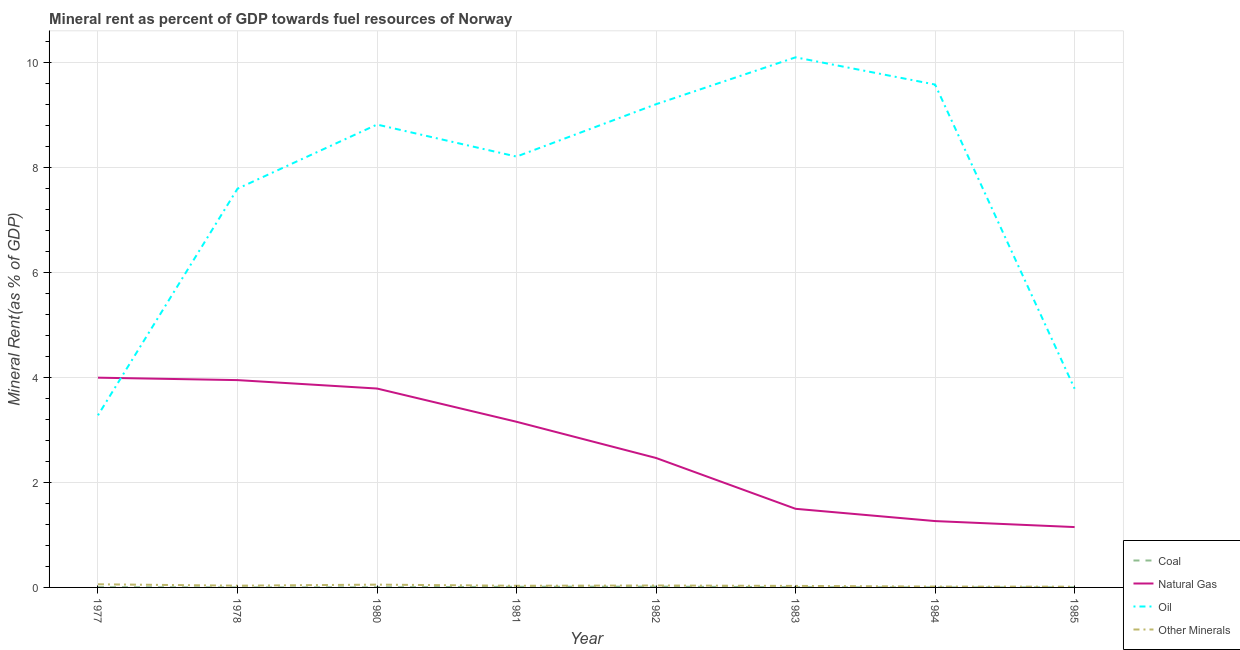Does the line corresponding to  rent of other minerals intersect with the line corresponding to natural gas rent?
Make the answer very short. No. Is the number of lines equal to the number of legend labels?
Ensure brevity in your answer.  Yes. What is the oil rent in 1981?
Provide a short and direct response. 8.21. Across all years, what is the maximum natural gas rent?
Your answer should be very brief. 4. Across all years, what is the minimum natural gas rent?
Your answer should be very brief. 1.15. What is the total oil rent in the graph?
Provide a short and direct response. 60.59. What is the difference between the oil rent in 1980 and that in 1983?
Make the answer very short. -1.28. What is the difference between the oil rent in 1982 and the coal rent in 1980?
Your answer should be very brief. 9.21. What is the average coal rent per year?
Provide a short and direct response. 0.01. In the year 1978, what is the difference between the  rent of other minerals and coal rent?
Ensure brevity in your answer.  0.03. What is the ratio of the coal rent in 1977 to that in 1980?
Your response must be concise. 1.97. What is the difference between the highest and the second highest  rent of other minerals?
Ensure brevity in your answer.  0.01. What is the difference between the highest and the lowest coal rent?
Offer a very short reply. 0.02. In how many years, is the  rent of other minerals greater than the average  rent of other minerals taken over all years?
Give a very brief answer. 3. Is the natural gas rent strictly less than the  rent of other minerals over the years?
Ensure brevity in your answer.  No. What is the difference between two consecutive major ticks on the Y-axis?
Offer a terse response. 2. Does the graph contain any zero values?
Offer a terse response. No. Where does the legend appear in the graph?
Offer a terse response. Bottom right. What is the title of the graph?
Your answer should be compact. Mineral rent as percent of GDP towards fuel resources of Norway. Does "Other greenhouse gases" appear as one of the legend labels in the graph?
Offer a very short reply. No. What is the label or title of the Y-axis?
Your answer should be very brief. Mineral Rent(as % of GDP). What is the Mineral Rent(as % of GDP) in Coal in 1977?
Provide a succinct answer. 0. What is the Mineral Rent(as % of GDP) of Natural Gas in 1977?
Provide a succinct answer. 4. What is the Mineral Rent(as % of GDP) in Oil in 1977?
Your response must be concise. 3.28. What is the Mineral Rent(as % of GDP) of Other Minerals in 1977?
Provide a short and direct response. 0.06. What is the Mineral Rent(as % of GDP) in Coal in 1978?
Your answer should be very brief. 0. What is the Mineral Rent(as % of GDP) of Natural Gas in 1978?
Provide a short and direct response. 3.95. What is the Mineral Rent(as % of GDP) of Oil in 1978?
Provide a succinct answer. 7.6. What is the Mineral Rent(as % of GDP) of Other Minerals in 1978?
Give a very brief answer. 0.03. What is the Mineral Rent(as % of GDP) in Coal in 1980?
Give a very brief answer. 0. What is the Mineral Rent(as % of GDP) of Natural Gas in 1980?
Make the answer very short. 3.79. What is the Mineral Rent(as % of GDP) of Oil in 1980?
Offer a very short reply. 8.82. What is the Mineral Rent(as % of GDP) in Other Minerals in 1980?
Make the answer very short. 0.05. What is the Mineral Rent(as % of GDP) in Coal in 1981?
Offer a very short reply. 0.01. What is the Mineral Rent(as % of GDP) of Natural Gas in 1981?
Provide a succinct answer. 3.16. What is the Mineral Rent(as % of GDP) of Oil in 1981?
Keep it short and to the point. 8.21. What is the Mineral Rent(as % of GDP) of Other Minerals in 1981?
Your response must be concise. 0.03. What is the Mineral Rent(as % of GDP) in Coal in 1982?
Make the answer very short. 0.02. What is the Mineral Rent(as % of GDP) in Natural Gas in 1982?
Offer a terse response. 2.47. What is the Mineral Rent(as % of GDP) in Oil in 1982?
Your response must be concise. 9.21. What is the Mineral Rent(as % of GDP) in Other Minerals in 1982?
Offer a very short reply. 0.04. What is the Mineral Rent(as % of GDP) of Coal in 1983?
Your response must be concise. 0. What is the Mineral Rent(as % of GDP) of Natural Gas in 1983?
Give a very brief answer. 1.5. What is the Mineral Rent(as % of GDP) in Oil in 1983?
Your answer should be compact. 10.1. What is the Mineral Rent(as % of GDP) of Other Minerals in 1983?
Your answer should be very brief. 0.03. What is the Mineral Rent(as % of GDP) in Coal in 1984?
Ensure brevity in your answer.  0. What is the Mineral Rent(as % of GDP) of Natural Gas in 1984?
Provide a succinct answer. 1.26. What is the Mineral Rent(as % of GDP) in Oil in 1984?
Your answer should be compact. 9.58. What is the Mineral Rent(as % of GDP) in Other Minerals in 1984?
Provide a succinct answer. 0.02. What is the Mineral Rent(as % of GDP) in Coal in 1985?
Ensure brevity in your answer.  0. What is the Mineral Rent(as % of GDP) in Natural Gas in 1985?
Offer a terse response. 1.15. What is the Mineral Rent(as % of GDP) in Oil in 1985?
Ensure brevity in your answer.  3.79. What is the Mineral Rent(as % of GDP) in Other Minerals in 1985?
Keep it short and to the point. 0.01. Across all years, what is the maximum Mineral Rent(as % of GDP) of Coal?
Offer a very short reply. 0.02. Across all years, what is the maximum Mineral Rent(as % of GDP) of Natural Gas?
Offer a very short reply. 4. Across all years, what is the maximum Mineral Rent(as % of GDP) in Oil?
Offer a very short reply. 10.1. Across all years, what is the maximum Mineral Rent(as % of GDP) of Other Minerals?
Make the answer very short. 0.06. Across all years, what is the minimum Mineral Rent(as % of GDP) in Coal?
Your answer should be compact. 0. Across all years, what is the minimum Mineral Rent(as % of GDP) in Natural Gas?
Your answer should be very brief. 1.15. Across all years, what is the minimum Mineral Rent(as % of GDP) in Oil?
Offer a terse response. 3.28. Across all years, what is the minimum Mineral Rent(as % of GDP) of Other Minerals?
Offer a terse response. 0.01. What is the total Mineral Rent(as % of GDP) in Coal in the graph?
Make the answer very short. 0.04. What is the total Mineral Rent(as % of GDP) of Natural Gas in the graph?
Your response must be concise. 21.27. What is the total Mineral Rent(as % of GDP) of Oil in the graph?
Give a very brief answer. 60.59. What is the total Mineral Rent(as % of GDP) of Other Minerals in the graph?
Your response must be concise. 0.28. What is the difference between the Mineral Rent(as % of GDP) in Coal in 1977 and that in 1978?
Give a very brief answer. 0. What is the difference between the Mineral Rent(as % of GDP) of Natural Gas in 1977 and that in 1978?
Offer a very short reply. 0.05. What is the difference between the Mineral Rent(as % of GDP) of Oil in 1977 and that in 1978?
Your response must be concise. -4.32. What is the difference between the Mineral Rent(as % of GDP) of Other Minerals in 1977 and that in 1978?
Keep it short and to the point. 0.03. What is the difference between the Mineral Rent(as % of GDP) of Coal in 1977 and that in 1980?
Offer a very short reply. 0. What is the difference between the Mineral Rent(as % of GDP) in Natural Gas in 1977 and that in 1980?
Your answer should be very brief. 0.21. What is the difference between the Mineral Rent(as % of GDP) of Oil in 1977 and that in 1980?
Ensure brevity in your answer.  -5.54. What is the difference between the Mineral Rent(as % of GDP) in Other Minerals in 1977 and that in 1980?
Offer a very short reply. 0.01. What is the difference between the Mineral Rent(as % of GDP) of Coal in 1977 and that in 1981?
Your answer should be very brief. -0.01. What is the difference between the Mineral Rent(as % of GDP) of Natural Gas in 1977 and that in 1981?
Your response must be concise. 0.84. What is the difference between the Mineral Rent(as % of GDP) of Oil in 1977 and that in 1981?
Make the answer very short. -4.93. What is the difference between the Mineral Rent(as % of GDP) in Other Minerals in 1977 and that in 1981?
Offer a terse response. 0.03. What is the difference between the Mineral Rent(as % of GDP) of Coal in 1977 and that in 1982?
Your response must be concise. -0.01. What is the difference between the Mineral Rent(as % of GDP) of Natural Gas in 1977 and that in 1982?
Your answer should be very brief. 1.53. What is the difference between the Mineral Rent(as % of GDP) in Oil in 1977 and that in 1982?
Provide a short and direct response. -5.93. What is the difference between the Mineral Rent(as % of GDP) in Other Minerals in 1977 and that in 1982?
Your answer should be very brief. 0.02. What is the difference between the Mineral Rent(as % of GDP) of Natural Gas in 1977 and that in 1983?
Your answer should be compact. 2.5. What is the difference between the Mineral Rent(as % of GDP) of Oil in 1977 and that in 1983?
Provide a short and direct response. -6.82. What is the difference between the Mineral Rent(as % of GDP) of Other Minerals in 1977 and that in 1983?
Ensure brevity in your answer.  0.03. What is the difference between the Mineral Rent(as % of GDP) of Coal in 1977 and that in 1984?
Provide a succinct answer. 0. What is the difference between the Mineral Rent(as % of GDP) in Natural Gas in 1977 and that in 1984?
Your answer should be very brief. 2.73. What is the difference between the Mineral Rent(as % of GDP) of Oil in 1977 and that in 1984?
Your answer should be very brief. -6.3. What is the difference between the Mineral Rent(as % of GDP) of Other Minerals in 1977 and that in 1984?
Provide a succinct answer. 0.04. What is the difference between the Mineral Rent(as % of GDP) in Coal in 1977 and that in 1985?
Keep it short and to the point. 0. What is the difference between the Mineral Rent(as % of GDP) of Natural Gas in 1977 and that in 1985?
Offer a terse response. 2.85. What is the difference between the Mineral Rent(as % of GDP) of Oil in 1977 and that in 1985?
Make the answer very short. -0.51. What is the difference between the Mineral Rent(as % of GDP) of Other Minerals in 1977 and that in 1985?
Your answer should be very brief. 0.05. What is the difference between the Mineral Rent(as % of GDP) in Coal in 1978 and that in 1980?
Keep it short and to the point. -0. What is the difference between the Mineral Rent(as % of GDP) of Natural Gas in 1978 and that in 1980?
Provide a succinct answer. 0.16. What is the difference between the Mineral Rent(as % of GDP) of Oil in 1978 and that in 1980?
Give a very brief answer. -1.22. What is the difference between the Mineral Rent(as % of GDP) of Other Minerals in 1978 and that in 1980?
Ensure brevity in your answer.  -0.02. What is the difference between the Mineral Rent(as % of GDP) in Coal in 1978 and that in 1981?
Provide a short and direct response. -0.01. What is the difference between the Mineral Rent(as % of GDP) of Natural Gas in 1978 and that in 1981?
Make the answer very short. 0.79. What is the difference between the Mineral Rent(as % of GDP) in Oil in 1978 and that in 1981?
Give a very brief answer. -0.61. What is the difference between the Mineral Rent(as % of GDP) in Other Minerals in 1978 and that in 1981?
Offer a very short reply. 0. What is the difference between the Mineral Rent(as % of GDP) in Coal in 1978 and that in 1982?
Your response must be concise. -0.01. What is the difference between the Mineral Rent(as % of GDP) in Natural Gas in 1978 and that in 1982?
Keep it short and to the point. 1.48. What is the difference between the Mineral Rent(as % of GDP) in Oil in 1978 and that in 1982?
Your answer should be compact. -1.61. What is the difference between the Mineral Rent(as % of GDP) in Other Minerals in 1978 and that in 1982?
Provide a short and direct response. -0. What is the difference between the Mineral Rent(as % of GDP) in Coal in 1978 and that in 1983?
Your answer should be compact. -0. What is the difference between the Mineral Rent(as % of GDP) in Natural Gas in 1978 and that in 1983?
Your answer should be very brief. 2.45. What is the difference between the Mineral Rent(as % of GDP) of Oil in 1978 and that in 1983?
Offer a terse response. -2.5. What is the difference between the Mineral Rent(as % of GDP) of Other Minerals in 1978 and that in 1983?
Ensure brevity in your answer.  0. What is the difference between the Mineral Rent(as % of GDP) in Natural Gas in 1978 and that in 1984?
Your response must be concise. 2.69. What is the difference between the Mineral Rent(as % of GDP) of Oil in 1978 and that in 1984?
Offer a terse response. -1.98. What is the difference between the Mineral Rent(as % of GDP) in Other Minerals in 1978 and that in 1984?
Your answer should be compact. 0.02. What is the difference between the Mineral Rent(as % of GDP) in Coal in 1978 and that in 1985?
Give a very brief answer. -0. What is the difference between the Mineral Rent(as % of GDP) in Natural Gas in 1978 and that in 1985?
Keep it short and to the point. 2.8. What is the difference between the Mineral Rent(as % of GDP) of Oil in 1978 and that in 1985?
Offer a very short reply. 3.81. What is the difference between the Mineral Rent(as % of GDP) of Other Minerals in 1978 and that in 1985?
Your response must be concise. 0.02. What is the difference between the Mineral Rent(as % of GDP) in Coal in 1980 and that in 1981?
Your answer should be very brief. -0.01. What is the difference between the Mineral Rent(as % of GDP) in Natural Gas in 1980 and that in 1981?
Your answer should be compact. 0.63. What is the difference between the Mineral Rent(as % of GDP) of Oil in 1980 and that in 1981?
Offer a very short reply. 0.61. What is the difference between the Mineral Rent(as % of GDP) of Other Minerals in 1980 and that in 1981?
Offer a very short reply. 0.02. What is the difference between the Mineral Rent(as % of GDP) in Coal in 1980 and that in 1982?
Give a very brief answer. -0.01. What is the difference between the Mineral Rent(as % of GDP) in Natural Gas in 1980 and that in 1982?
Keep it short and to the point. 1.32. What is the difference between the Mineral Rent(as % of GDP) of Oil in 1980 and that in 1982?
Make the answer very short. -0.39. What is the difference between the Mineral Rent(as % of GDP) of Other Minerals in 1980 and that in 1982?
Offer a terse response. 0.02. What is the difference between the Mineral Rent(as % of GDP) in Coal in 1980 and that in 1983?
Keep it short and to the point. -0. What is the difference between the Mineral Rent(as % of GDP) in Natural Gas in 1980 and that in 1983?
Your answer should be compact. 2.29. What is the difference between the Mineral Rent(as % of GDP) of Oil in 1980 and that in 1983?
Provide a succinct answer. -1.28. What is the difference between the Mineral Rent(as % of GDP) in Other Minerals in 1980 and that in 1983?
Keep it short and to the point. 0.02. What is the difference between the Mineral Rent(as % of GDP) in Coal in 1980 and that in 1984?
Offer a terse response. 0. What is the difference between the Mineral Rent(as % of GDP) in Natural Gas in 1980 and that in 1984?
Ensure brevity in your answer.  2.53. What is the difference between the Mineral Rent(as % of GDP) of Oil in 1980 and that in 1984?
Your answer should be very brief. -0.76. What is the difference between the Mineral Rent(as % of GDP) of Other Minerals in 1980 and that in 1984?
Your answer should be compact. 0.04. What is the difference between the Mineral Rent(as % of GDP) of Coal in 1980 and that in 1985?
Your answer should be compact. -0. What is the difference between the Mineral Rent(as % of GDP) in Natural Gas in 1980 and that in 1985?
Keep it short and to the point. 2.64. What is the difference between the Mineral Rent(as % of GDP) of Oil in 1980 and that in 1985?
Give a very brief answer. 5.03. What is the difference between the Mineral Rent(as % of GDP) of Other Minerals in 1980 and that in 1985?
Ensure brevity in your answer.  0.04. What is the difference between the Mineral Rent(as % of GDP) in Coal in 1981 and that in 1982?
Your answer should be compact. -0. What is the difference between the Mineral Rent(as % of GDP) in Natural Gas in 1981 and that in 1982?
Offer a very short reply. 0.69. What is the difference between the Mineral Rent(as % of GDP) in Oil in 1981 and that in 1982?
Provide a succinct answer. -1. What is the difference between the Mineral Rent(as % of GDP) of Other Minerals in 1981 and that in 1982?
Provide a succinct answer. -0.01. What is the difference between the Mineral Rent(as % of GDP) of Coal in 1981 and that in 1983?
Provide a succinct answer. 0.01. What is the difference between the Mineral Rent(as % of GDP) in Natural Gas in 1981 and that in 1983?
Provide a succinct answer. 1.66. What is the difference between the Mineral Rent(as % of GDP) in Oil in 1981 and that in 1983?
Provide a short and direct response. -1.89. What is the difference between the Mineral Rent(as % of GDP) of Other Minerals in 1981 and that in 1983?
Your answer should be very brief. 0. What is the difference between the Mineral Rent(as % of GDP) in Coal in 1981 and that in 1984?
Ensure brevity in your answer.  0.01. What is the difference between the Mineral Rent(as % of GDP) in Natural Gas in 1981 and that in 1984?
Your answer should be compact. 1.89. What is the difference between the Mineral Rent(as % of GDP) in Oil in 1981 and that in 1984?
Provide a succinct answer. -1.37. What is the difference between the Mineral Rent(as % of GDP) in Other Minerals in 1981 and that in 1984?
Your answer should be compact. 0.02. What is the difference between the Mineral Rent(as % of GDP) in Coal in 1981 and that in 1985?
Make the answer very short. 0.01. What is the difference between the Mineral Rent(as % of GDP) in Natural Gas in 1981 and that in 1985?
Provide a succinct answer. 2.01. What is the difference between the Mineral Rent(as % of GDP) of Oil in 1981 and that in 1985?
Provide a short and direct response. 4.42. What is the difference between the Mineral Rent(as % of GDP) in Other Minerals in 1981 and that in 1985?
Keep it short and to the point. 0.02. What is the difference between the Mineral Rent(as % of GDP) of Coal in 1982 and that in 1983?
Your answer should be very brief. 0.01. What is the difference between the Mineral Rent(as % of GDP) of Natural Gas in 1982 and that in 1983?
Keep it short and to the point. 0.97. What is the difference between the Mineral Rent(as % of GDP) in Oil in 1982 and that in 1983?
Offer a very short reply. -0.89. What is the difference between the Mineral Rent(as % of GDP) of Other Minerals in 1982 and that in 1983?
Offer a very short reply. 0.01. What is the difference between the Mineral Rent(as % of GDP) of Coal in 1982 and that in 1984?
Ensure brevity in your answer.  0.02. What is the difference between the Mineral Rent(as % of GDP) of Natural Gas in 1982 and that in 1984?
Your answer should be very brief. 1.2. What is the difference between the Mineral Rent(as % of GDP) in Oil in 1982 and that in 1984?
Your answer should be compact. -0.37. What is the difference between the Mineral Rent(as % of GDP) in Other Minerals in 1982 and that in 1984?
Provide a succinct answer. 0.02. What is the difference between the Mineral Rent(as % of GDP) in Coal in 1982 and that in 1985?
Provide a succinct answer. 0.01. What is the difference between the Mineral Rent(as % of GDP) in Natural Gas in 1982 and that in 1985?
Provide a succinct answer. 1.32. What is the difference between the Mineral Rent(as % of GDP) in Oil in 1982 and that in 1985?
Ensure brevity in your answer.  5.42. What is the difference between the Mineral Rent(as % of GDP) in Other Minerals in 1982 and that in 1985?
Provide a short and direct response. 0.02. What is the difference between the Mineral Rent(as % of GDP) in Coal in 1983 and that in 1984?
Offer a very short reply. 0. What is the difference between the Mineral Rent(as % of GDP) in Natural Gas in 1983 and that in 1984?
Offer a very short reply. 0.23. What is the difference between the Mineral Rent(as % of GDP) in Oil in 1983 and that in 1984?
Provide a succinct answer. 0.52. What is the difference between the Mineral Rent(as % of GDP) of Other Minerals in 1983 and that in 1984?
Your answer should be very brief. 0.01. What is the difference between the Mineral Rent(as % of GDP) of Coal in 1983 and that in 1985?
Give a very brief answer. 0. What is the difference between the Mineral Rent(as % of GDP) of Natural Gas in 1983 and that in 1985?
Provide a succinct answer. 0.35. What is the difference between the Mineral Rent(as % of GDP) of Oil in 1983 and that in 1985?
Your answer should be compact. 6.32. What is the difference between the Mineral Rent(as % of GDP) in Other Minerals in 1983 and that in 1985?
Make the answer very short. 0.01. What is the difference between the Mineral Rent(as % of GDP) in Coal in 1984 and that in 1985?
Your answer should be compact. -0. What is the difference between the Mineral Rent(as % of GDP) in Natural Gas in 1984 and that in 1985?
Your answer should be compact. 0.11. What is the difference between the Mineral Rent(as % of GDP) of Oil in 1984 and that in 1985?
Provide a succinct answer. 5.8. What is the difference between the Mineral Rent(as % of GDP) of Other Minerals in 1984 and that in 1985?
Your answer should be compact. 0. What is the difference between the Mineral Rent(as % of GDP) in Coal in 1977 and the Mineral Rent(as % of GDP) in Natural Gas in 1978?
Offer a very short reply. -3.95. What is the difference between the Mineral Rent(as % of GDP) of Coal in 1977 and the Mineral Rent(as % of GDP) of Oil in 1978?
Provide a succinct answer. -7.59. What is the difference between the Mineral Rent(as % of GDP) in Coal in 1977 and the Mineral Rent(as % of GDP) in Other Minerals in 1978?
Offer a very short reply. -0.03. What is the difference between the Mineral Rent(as % of GDP) of Natural Gas in 1977 and the Mineral Rent(as % of GDP) of Oil in 1978?
Your response must be concise. -3.6. What is the difference between the Mineral Rent(as % of GDP) in Natural Gas in 1977 and the Mineral Rent(as % of GDP) in Other Minerals in 1978?
Your response must be concise. 3.96. What is the difference between the Mineral Rent(as % of GDP) of Oil in 1977 and the Mineral Rent(as % of GDP) of Other Minerals in 1978?
Give a very brief answer. 3.25. What is the difference between the Mineral Rent(as % of GDP) of Coal in 1977 and the Mineral Rent(as % of GDP) of Natural Gas in 1980?
Provide a succinct answer. -3.79. What is the difference between the Mineral Rent(as % of GDP) of Coal in 1977 and the Mineral Rent(as % of GDP) of Oil in 1980?
Provide a short and direct response. -8.82. What is the difference between the Mineral Rent(as % of GDP) in Coal in 1977 and the Mineral Rent(as % of GDP) in Other Minerals in 1980?
Keep it short and to the point. -0.05. What is the difference between the Mineral Rent(as % of GDP) in Natural Gas in 1977 and the Mineral Rent(as % of GDP) in Oil in 1980?
Provide a short and direct response. -4.82. What is the difference between the Mineral Rent(as % of GDP) in Natural Gas in 1977 and the Mineral Rent(as % of GDP) in Other Minerals in 1980?
Your answer should be compact. 3.94. What is the difference between the Mineral Rent(as % of GDP) in Oil in 1977 and the Mineral Rent(as % of GDP) in Other Minerals in 1980?
Offer a very short reply. 3.23. What is the difference between the Mineral Rent(as % of GDP) in Coal in 1977 and the Mineral Rent(as % of GDP) in Natural Gas in 1981?
Offer a terse response. -3.15. What is the difference between the Mineral Rent(as % of GDP) of Coal in 1977 and the Mineral Rent(as % of GDP) of Oil in 1981?
Your answer should be compact. -8.21. What is the difference between the Mineral Rent(as % of GDP) in Coal in 1977 and the Mineral Rent(as % of GDP) in Other Minerals in 1981?
Give a very brief answer. -0.03. What is the difference between the Mineral Rent(as % of GDP) of Natural Gas in 1977 and the Mineral Rent(as % of GDP) of Oil in 1981?
Provide a short and direct response. -4.21. What is the difference between the Mineral Rent(as % of GDP) in Natural Gas in 1977 and the Mineral Rent(as % of GDP) in Other Minerals in 1981?
Provide a succinct answer. 3.97. What is the difference between the Mineral Rent(as % of GDP) of Oil in 1977 and the Mineral Rent(as % of GDP) of Other Minerals in 1981?
Offer a very short reply. 3.25. What is the difference between the Mineral Rent(as % of GDP) in Coal in 1977 and the Mineral Rent(as % of GDP) in Natural Gas in 1982?
Provide a succinct answer. -2.46. What is the difference between the Mineral Rent(as % of GDP) of Coal in 1977 and the Mineral Rent(as % of GDP) of Oil in 1982?
Ensure brevity in your answer.  -9.2. What is the difference between the Mineral Rent(as % of GDP) of Coal in 1977 and the Mineral Rent(as % of GDP) of Other Minerals in 1982?
Keep it short and to the point. -0.03. What is the difference between the Mineral Rent(as % of GDP) in Natural Gas in 1977 and the Mineral Rent(as % of GDP) in Oil in 1982?
Offer a very short reply. -5.21. What is the difference between the Mineral Rent(as % of GDP) in Natural Gas in 1977 and the Mineral Rent(as % of GDP) in Other Minerals in 1982?
Offer a terse response. 3.96. What is the difference between the Mineral Rent(as % of GDP) in Oil in 1977 and the Mineral Rent(as % of GDP) in Other Minerals in 1982?
Ensure brevity in your answer.  3.24. What is the difference between the Mineral Rent(as % of GDP) in Coal in 1977 and the Mineral Rent(as % of GDP) in Natural Gas in 1983?
Give a very brief answer. -1.49. What is the difference between the Mineral Rent(as % of GDP) in Coal in 1977 and the Mineral Rent(as % of GDP) in Oil in 1983?
Provide a short and direct response. -10.1. What is the difference between the Mineral Rent(as % of GDP) of Coal in 1977 and the Mineral Rent(as % of GDP) of Other Minerals in 1983?
Keep it short and to the point. -0.02. What is the difference between the Mineral Rent(as % of GDP) of Natural Gas in 1977 and the Mineral Rent(as % of GDP) of Oil in 1983?
Keep it short and to the point. -6.1. What is the difference between the Mineral Rent(as % of GDP) in Natural Gas in 1977 and the Mineral Rent(as % of GDP) in Other Minerals in 1983?
Your answer should be compact. 3.97. What is the difference between the Mineral Rent(as % of GDP) in Oil in 1977 and the Mineral Rent(as % of GDP) in Other Minerals in 1983?
Your response must be concise. 3.25. What is the difference between the Mineral Rent(as % of GDP) in Coal in 1977 and the Mineral Rent(as % of GDP) in Natural Gas in 1984?
Offer a terse response. -1.26. What is the difference between the Mineral Rent(as % of GDP) in Coal in 1977 and the Mineral Rent(as % of GDP) in Oil in 1984?
Give a very brief answer. -9.58. What is the difference between the Mineral Rent(as % of GDP) in Coal in 1977 and the Mineral Rent(as % of GDP) in Other Minerals in 1984?
Offer a terse response. -0.01. What is the difference between the Mineral Rent(as % of GDP) of Natural Gas in 1977 and the Mineral Rent(as % of GDP) of Oil in 1984?
Offer a terse response. -5.59. What is the difference between the Mineral Rent(as % of GDP) of Natural Gas in 1977 and the Mineral Rent(as % of GDP) of Other Minerals in 1984?
Offer a very short reply. 3.98. What is the difference between the Mineral Rent(as % of GDP) in Oil in 1977 and the Mineral Rent(as % of GDP) in Other Minerals in 1984?
Your response must be concise. 3.26. What is the difference between the Mineral Rent(as % of GDP) in Coal in 1977 and the Mineral Rent(as % of GDP) in Natural Gas in 1985?
Your response must be concise. -1.15. What is the difference between the Mineral Rent(as % of GDP) of Coal in 1977 and the Mineral Rent(as % of GDP) of Oil in 1985?
Offer a terse response. -3.78. What is the difference between the Mineral Rent(as % of GDP) in Coal in 1977 and the Mineral Rent(as % of GDP) in Other Minerals in 1985?
Your answer should be very brief. -0.01. What is the difference between the Mineral Rent(as % of GDP) in Natural Gas in 1977 and the Mineral Rent(as % of GDP) in Oil in 1985?
Keep it short and to the point. 0.21. What is the difference between the Mineral Rent(as % of GDP) in Natural Gas in 1977 and the Mineral Rent(as % of GDP) in Other Minerals in 1985?
Your answer should be compact. 3.98. What is the difference between the Mineral Rent(as % of GDP) in Oil in 1977 and the Mineral Rent(as % of GDP) in Other Minerals in 1985?
Make the answer very short. 3.27. What is the difference between the Mineral Rent(as % of GDP) in Coal in 1978 and the Mineral Rent(as % of GDP) in Natural Gas in 1980?
Offer a very short reply. -3.79. What is the difference between the Mineral Rent(as % of GDP) in Coal in 1978 and the Mineral Rent(as % of GDP) in Oil in 1980?
Your answer should be compact. -8.82. What is the difference between the Mineral Rent(as % of GDP) in Coal in 1978 and the Mineral Rent(as % of GDP) in Other Minerals in 1980?
Make the answer very short. -0.05. What is the difference between the Mineral Rent(as % of GDP) in Natural Gas in 1978 and the Mineral Rent(as % of GDP) in Oil in 1980?
Your response must be concise. -4.87. What is the difference between the Mineral Rent(as % of GDP) in Natural Gas in 1978 and the Mineral Rent(as % of GDP) in Other Minerals in 1980?
Your answer should be very brief. 3.9. What is the difference between the Mineral Rent(as % of GDP) of Oil in 1978 and the Mineral Rent(as % of GDP) of Other Minerals in 1980?
Give a very brief answer. 7.55. What is the difference between the Mineral Rent(as % of GDP) in Coal in 1978 and the Mineral Rent(as % of GDP) in Natural Gas in 1981?
Provide a succinct answer. -3.16. What is the difference between the Mineral Rent(as % of GDP) in Coal in 1978 and the Mineral Rent(as % of GDP) in Oil in 1981?
Provide a succinct answer. -8.21. What is the difference between the Mineral Rent(as % of GDP) of Coal in 1978 and the Mineral Rent(as % of GDP) of Other Minerals in 1981?
Your answer should be very brief. -0.03. What is the difference between the Mineral Rent(as % of GDP) of Natural Gas in 1978 and the Mineral Rent(as % of GDP) of Oil in 1981?
Provide a succinct answer. -4.26. What is the difference between the Mineral Rent(as % of GDP) of Natural Gas in 1978 and the Mineral Rent(as % of GDP) of Other Minerals in 1981?
Ensure brevity in your answer.  3.92. What is the difference between the Mineral Rent(as % of GDP) of Oil in 1978 and the Mineral Rent(as % of GDP) of Other Minerals in 1981?
Your response must be concise. 7.57. What is the difference between the Mineral Rent(as % of GDP) in Coal in 1978 and the Mineral Rent(as % of GDP) in Natural Gas in 1982?
Your response must be concise. -2.47. What is the difference between the Mineral Rent(as % of GDP) in Coal in 1978 and the Mineral Rent(as % of GDP) in Oil in 1982?
Give a very brief answer. -9.21. What is the difference between the Mineral Rent(as % of GDP) of Coal in 1978 and the Mineral Rent(as % of GDP) of Other Minerals in 1982?
Your answer should be compact. -0.04. What is the difference between the Mineral Rent(as % of GDP) of Natural Gas in 1978 and the Mineral Rent(as % of GDP) of Oil in 1982?
Keep it short and to the point. -5.26. What is the difference between the Mineral Rent(as % of GDP) in Natural Gas in 1978 and the Mineral Rent(as % of GDP) in Other Minerals in 1982?
Make the answer very short. 3.91. What is the difference between the Mineral Rent(as % of GDP) of Oil in 1978 and the Mineral Rent(as % of GDP) of Other Minerals in 1982?
Your response must be concise. 7.56. What is the difference between the Mineral Rent(as % of GDP) in Coal in 1978 and the Mineral Rent(as % of GDP) in Natural Gas in 1983?
Ensure brevity in your answer.  -1.5. What is the difference between the Mineral Rent(as % of GDP) of Coal in 1978 and the Mineral Rent(as % of GDP) of Oil in 1983?
Offer a very short reply. -10.1. What is the difference between the Mineral Rent(as % of GDP) of Coal in 1978 and the Mineral Rent(as % of GDP) of Other Minerals in 1983?
Provide a short and direct response. -0.03. What is the difference between the Mineral Rent(as % of GDP) in Natural Gas in 1978 and the Mineral Rent(as % of GDP) in Oil in 1983?
Keep it short and to the point. -6.15. What is the difference between the Mineral Rent(as % of GDP) of Natural Gas in 1978 and the Mineral Rent(as % of GDP) of Other Minerals in 1983?
Offer a terse response. 3.92. What is the difference between the Mineral Rent(as % of GDP) of Oil in 1978 and the Mineral Rent(as % of GDP) of Other Minerals in 1983?
Provide a short and direct response. 7.57. What is the difference between the Mineral Rent(as % of GDP) in Coal in 1978 and the Mineral Rent(as % of GDP) in Natural Gas in 1984?
Keep it short and to the point. -1.26. What is the difference between the Mineral Rent(as % of GDP) of Coal in 1978 and the Mineral Rent(as % of GDP) of Oil in 1984?
Keep it short and to the point. -9.58. What is the difference between the Mineral Rent(as % of GDP) in Coal in 1978 and the Mineral Rent(as % of GDP) in Other Minerals in 1984?
Provide a short and direct response. -0.02. What is the difference between the Mineral Rent(as % of GDP) of Natural Gas in 1978 and the Mineral Rent(as % of GDP) of Oil in 1984?
Provide a short and direct response. -5.63. What is the difference between the Mineral Rent(as % of GDP) of Natural Gas in 1978 and the Mineral Rent(as % of GDP) of Other Minerals in 1984?
Offer a very short reply. 3.93. What is the difference between the Mineral Rent(as % of GDP) in Oil in 1978 and the Mineral Rent(as % of GDP) in Other Minerals in 1984?
Your answer should be very brief. 7.58. What is the difference between the Mineral Rent(as % of GDP) of Coal in 1978 and the Mineral Rent(as % of GDP) of Natural Gas in 1985?
Give a very brief answer. -1.15. What is the difference between the Mineral Rent(as % of GDP) in Coal in 1978 and the Mineral Rent(as % of GDP) in Oil in 1985?
Provide a succinct answer. -3.79. What is the difference between the Mineral Rent(as % of GDP) of Coal in 1978 and the Mineral Rent(as % of GDP) of Other Minerals in 1985?
Your answer should be very brief. -0.01. What is the difference between the Mineral Rent(as % of GDP) in Natural Gas in 1978 and the Mineral Rent(as % of GDP) in Oil in 1985?
Give a very brief answer. 0.16. What is the difference between the Mineral Rent(as % of GDP) of Natural Gas in 1978 and the Mineral Rent(as % of GDP) of Other Minerals in 1985?
Make the answer very short. 3.94. What is the difference between the Mineral Rent(as % of GDP) of Oil in 1978 and the Mineral Rent(as % of GDP) of Other Minerals in 1985?
Your response must be concise. 7.58. What is the difference between the Mineral Rent(as % of GDP) in Coal in 1980 and the Mineral Rent(as % of GDP) in Natural Gas in 1981?
Your response must be concise. -3.15. What is the difference between the Mineral Rent(as % of GDP) of Coal in 1980 and the Mineral Rent(as % of GDP) of Oil in 1981?
Keep it short and to the point. -8.21. What is the difference between the Mineral Rent(as % of GDP) in Coal in 1980 and the Mineral Rent(as % of GDP) in Other Minerals in 1981?
Ensure brevity in your answer.  -0.03. What is the difference between the Mineral Rent(as % of GDP) of Natural Gas in 1980 and the Mineral Rent(as % of GDP) of Oil in 1981?
Make the answer very short. -4.42. What is the difference between the Mineral Rent(as % of GDP) in Natural Gas in 1980 and the Mineral Rent(as % of GDP) in Other Minerals in 1981?
Offer a terse response. 3.76. What is the difference between the Mineral Rent(as % of GDP) of Oil in 1980 and the Mineral Rent(as % of GDP) of Other Minerals in 1981?
Keep it short and to the point. 8.79. What is the difference between the Mineral Rent(as % of GDP) of Coal in 1980 and the Mineral Rent(as % of GDP) of Natural Gas in 1982?
Your response must be concise. -2.46. What is the difference between the Mineral Rent(as % of GDP) in Coal in 1980 and the Mineral Rent(as % of GDP) in Oil in 1982?
Your answer should be very brief. -9.21. What is the difference between the Mineral Rent(as % of GDP) in Coal in 1980 and the Mineral Rent(as % of GDP) in Other Minerals in 1982?
Offer a terse response. -0.03. What is the difference between the Mineral Rent(as % of GDP) in Natural Gas in 1980 and the Mineral Rent(as % of GDP) in Oil in 1982?
Give a very brief answer. -5.42. What is the difference between the Mineral Rent(as % of GDP) in Natural Gas in 1980 and the Mineral Rent(as % of GDP) in Other Minerals in 1982?
Offer a terse response. 3.75. What is the difference between the Mineral Rent(as % of GDP) in Oil in 1980 and the Mineral Rent(as % of GDP) in Other Minerals in 1982?
Your response must be concise. 8.78. What is the difference between the Mineral Rent(as % of GDP) in Coal in 1980 and the Mineral Rent(as % of GDP) in Natural Gas in 1983?
Give a very brief answer. -1.5. What is the difference between the Mineral Rent(as % of GDP) of Coal in 1980 and the Mineral Rent(as % of GDP) of Oil in 1983?
Keep it short and to the point. -10.1. What is the difference between the Mineral Rent(as % of GDP) of Coal in 1980 and the Mineral Rent(as % of GDP) of Other Minerals in 1983?
Offer a very short reply. -0.03. What is the difference between the Mineral Rent(as % of GDP) of Natural Gas in 1980 and the Mineral Rent(as % of GDP) of Oil in 1983?
Ensure brevity in your answer.  -6.31. What is the difference between the Mineral Rent(as % of GDP) in Natural Gas in 1980 and the Mineral Rent(as % of GDP) in Other Minerals in 1983?
Provide a succinct answer. 3.76. What is the difference between the Mineral Rent(as % of GDP) in Oil in 1980 and the Mineral Rent(as % of GDP) in Other Minerals in 1983?
Give a very brief answer. 8.79. What is the difference between the Mineral Rent(as % of GDP) of Coal in 1980 and the Mineral Rent(as % of GDP) of Natural Gas in 1984?
Keep it short and to the point. -1.26. What is the difference between the Mineral Rent(as % of GDP) of Coal in 1980 and the Mineral Rent(as % of GDP) of Oil in 1984?
Keep it short and to the point. -9.58. What is the difference between the Mineral Rent(as % of GDP) in Coal in 1980 and the Mineral Rent(as % of GDP) in Other Minerals in 1984?
Your answer should be very brief. -0.01. What is the difference between the Mineral Rent(as % of GDP) in Natural Gas in 1980 and the Mineral Rent(as % of GDP) in Oil in 1984?
Make the answer very short. -5.79. What is the difference between the Mineral Rent(as % of GDP) in Natural Gas in 1980 and the Mineral Rent(as % of GDP) in Other Minerals in 1984?
Offer a terse response. 3.77. What is the difference between the Mineral Rent(as % of GDP) in Oil in 1980 and the Mineral Rent(as % of GDP) in Other Minerals in 1984?
Your response must be concise. 8.8. What is the difference between the Mineral Rent(as % of GDP) of Coal in 1980 and the Mineral Rent(as % of GDP) of Natural Gas in 1985?
Offer a very short reply. -1.15. What is the difference between the Mineral Rent(as % of GDP) in Coal in 1980 and the Mineral Rent(as % of GDP) in Oil in 1985?
Offer a terse response. -3.78. What is the difference between the Mineral Rent(as % of GDP) in Coal in 1980 and the Mineral Rent(as % of GDP) in Other Minerals in 1985?
Your answer should be compact. -0.01. What is the difference between the Mineral Rent(as % of GDP) of Natural Gas in 1980 and the Mineral Rent(as % of GDP) of Oil in 1985?
Ensure brevity in your answer.  0. What is the difference between the Mineral Rent(as % of GDP) of Natural Gas in 1980 and the Mineral Rent(as % of GDP) of Other Minerals in 1985?
Give a very brief answer. 3.78. What is the difference between the Mineral Rent(as % of GDP) in Oil in 1980 and the Mineral Rent(as % of GDP) in Other Minerals in 1985?
Make the answer very short. 8.81. What is the difference between the Mineral Rent(as % of GDP) of Coal in 1981 and the Mineral Rent(as % of GDP) of Natural Gas in 1982?
Give a very brief answer. -2.45. What is the difference between the Mineral Rent(as % of GDP) in Coal in 1981 and the Mineral Rent(as % of GDP) in Oil in 1982?
Ensure brevity in your answer.  -9.2. What is the difference between the Mineral Rent(as % of GDP) of Coal in 1981 and the Mineral Rent(as % of GDP) of Other Minerals in 1982?
Offer a terse response. -0.02. What is the difference between the Mineral Rent(as % of GDP) in Natural Gas in 1981 and the Mineral Rent(as % of GDP) in Oil in 1982?
Give a very brief answer. -6.05. What is the difference between the Mineral Rent(as % of GDP) in Natural Gas in 1981 and the Mineral Rent(as % of GDP) in Other Minerals in 1982?
Ensure brevity in your answer.  3.12. What is the difference between the Mineral Rent(as % of GDP) of Oil in 1981 and the Mineral Rent(as % of GDP) of Other Minerals in 1982?
Offer a terse response. 8.17. What is the difference between the Mineral Rent(as % of GDP) in Coal in 1981 and the Mineral Rent(as % of GDP) in Natural Gas in 1983?
Offer a terse response. -1.49. What is the difference between the Mineral Rent(as % of GDP) of Coal in 1981 and the Mineral Rent(as % of GDP) of Oil in 1983?
Offer a very short reply. -10.09. What is the difference between the Mineral Rent(as % of GDP) of Coal in 1981 and the Mineral Rent(as % of GDP) of Other Minerals in 1983?
Offer a very short reply. -0.02. What is the difference between the Mineral Rent(as % of GDP) in Natural Gas in 1981 and the Mineral Rent(as % of GDP) in Oil in 1983?
Offer a very short reply. -6.95. What is the difference between the Mineral Rent(as % of GDP) of Natural Gas in 1981 and the Mineral Rent(as % of GDP) of Other Minerals in 1983?
Your answer should be compact. 3.13. What is the difference between the Mineral Rent(as % of GDP) in Oil in 1981 and the Mineral Rent(as % of GDP) in Other Minerals in 1983?
Give a very brief answer. 8.18. What is the difference between the Mineral Rent(as % of GDP) of Coal in 1981 and the Mineral Rent(as % of GDP) of Natural Gas in 1984?
Ensure brevity in your answer.  -1.25. What is the difference between the Mineral Rent(as % of GDP) of Coal in 1981 and the Mineral Rent(as % of GDP) of Oil in 1984?
Keep it short and to the point. -9.57. What is the difference between the Mineral Rent(as % of GDP) of Coal in 1981 and the Mineral Rent(as % of GDP) of Other Minerals in 1984?
Make the answer very short. -0. What is the difference between the Mineral Rent(as % of GDP) of Natural Gas in 1981 and the Mineral Rent(as % of GDP) of Oil in 1984?
Make the answer very short. -6.43. What is the difference between the Mineral Rent(as % of GDP) in Natural Gas in 1981 and the Mineral Rent(as % of GDP) in Other Minerals in 1984?
Provide a short and direct response. 3.14. What is the difference between the Mineral Rent(as % of GDP) in Oil in 1981 and the Mineral Rent(as % of GDP) in Other Minerals in 1984?
Provide a short and direct response. 8.19. What is the difference between the Mineral Rent(as % of GDP) of Coal in 1981 and the Mineral Rent(as % of GDP) of Natural Gas in 1985?
Ensure brevity in your answer.  -1.14. What is the difference between the Mineral Rent(as % of GDP) of Coal in 1981 and the Mineral Rent(as % of GDP) of Oil in 1985?
Your answer should be very brief. -3.77. What is the difference between the Mineral Rent(as % of GDP) of Coal in 1981 and the Mineral Rent(as % of GDP) of Other Minerals in 1985?
Provide a short and direct response. -0. What is the difference between the Mineral Rent(as % of GDP) in Natural Gas in 1981 and the Mineral Rent(as % of GDP) in Oil in 1985?
Make the answer very short. -0.63. What is the difference between the Mineral Rent(as % of GDP) of Natural Gas in 1981 and the Mineral Rent(as % of GDP) of Other Minerals in 1985?
Your response must be concise. 3.14. What is the difference between the Mineral Rent(as % of GDP) of Oil in 1981 and the Mineral Rent(as % of GDP) of Other Minerals in 1985?
Ensure brevity in your answer.  8.2. What is the difference between the Mineral Rent(as % of GDP) in Coal in 1982 and the Mineral Rent(as % of GDP) in Natural Gas in 1983?
Offer a terse response. -1.48. What is the difference between the Mineral Rent(as % of GDP) in Coal in 1982 and the Mineral Rent(as % of GDP) in Oil in 1983?
Provide a succinct answer. -10.09. What is the difference between the Mineral Rent(as % of GDP) in Coal in 1982 and the Mineral Rent(as % of GDP) in Other Minerals in 1983?
Give a very brief answer. -0.01. What is the difference between the Mineral Rent(as % of GDP) in Natural Gas in 1982 and the Mineral Rent(as % of GDP) in Oil in 1983?
Keep it short and to the point. -7.64. What is the difference between the Mineral Rent(as % of GDP) of Natural Gas in 1982 and the Mineral Rent(as % of GDP) of Other Minerals in 1983?
Ensure brevity in your answer.  2.44. What is the difference between the Mineral Rent(as % of GDP) in Oil in 1982 and the Mineral Rent(as % of GDP) in Other Minerals in 1983?
Offer a terse response. 9.18. What is the difference between the Mineral Rent(as % of GDP) of Coal in 1982 and the Mineral Rent(as % of GDP) of Natural Gas in 1984?
Your answer should be very brief. -1.25. What is the difference between the Mineral Rent(as % of GDP) in Coal in 1982 and the Mineral Rent(as % of GDP) in Oil in 1984?
Keep it short and to the point. -9.57. What is the difference between the Mineral Rent(as % of GDP) in Coal in 1982 and the Mineral Rent(as % of GDP) in Other Minerals in 1984?
Give a very brief answer. -0. What is the difference between the Mineral Rent(as % of GDP) of Natural Gas in 1982 and the Mineral Rent(as % of GDP) of Oil in 1984?
Give a very brief answer. -7.12. What is the difference between the Mineral Rent(as % of GDP) of Natural Gas in 1982 and the Mineral Rent(as % of GDP) of Other Minerals in 1984?
Your answer should be very brief. 2.45. What is the difference between the Mineral Rent(as % of GDP) of Oil in 1982 and the Mineral Rent(as % of GDP) of Other Minerals in 1984?
Make the answer very short. 9.19. What is the difference between the Mineral Rent(as % of GDP) of Coal in 1982 and the Mineral Rent(as % of GDP) of Natural Gas in 1985?
Give a very brief answer. -1.13. What is the difference between the Mineral Rent(as % of GDP) of Coal in 1982 and the Mineral Rent(as % of GDP) of Oil in 1985?
Offer a terse response. -3.77. What is the difference between the Mineral Rent(as % of GDP) of Coal in 1982 and the Mineral Rent(as % of GDP) of Other Minerals in 1985?
Your answer should be compact. 0. What is the difference between the Mineral Rent(as % of GDP) in Natural Gas in 1982 and the Mineral Rent(as % of GDP) in Oil in 1985?
Provide a succinct answer. -1.32. What is the difference between the Mineral Rent(as % of GDP) in Natural Gas in 1982 and the Mineral Rent(as % of GDP) in Other Minerals in 1985?
Give a very brief answer. 2.45. What is the difference between the Mineral Rent(as % of GDP) of Oil in 1982 and the Mineral Rent(as % of GDP) of Other Minerals in 1985?
Offer a very short reply. 9.19. What is the difference between the Mineral Rent(as % of GDP) in Coal in 1983 and the Mineral Rent(as % of GDP) in Natural Gas in 1984?
Provide a succinct answer. -1.26. What is the difference between the Mineral Rent(as % of GDP) of Coal in 1983 and the Mineral Rent(as % of GDP) of Oil in 1984?
Offer a very short reply. -9.58. What is the difference between the Mineral Rent(as % of GDP) in Coal in 1983 and the Mineral Rent(as % of GDP) in Other Minerals in 1984?
Your answer should be very brief. -0.01. What is the difference between the Mineral Rent(as % of GDP) in Natural Gas in 1983 and the Mineral Rent(as % of GDP) in Oil in 1984?
Offer a terse response. -8.09. What is the difference between the Mineral Rent(as % of GDP) in Natural Gas in 1983 and the Mineral Rent(as % of GDP) in Other Minerals in 1984?
Give a very brief answer. 1.48. What is the difference between the Mineral Rent(as % of GDP) in Oil in 1983 and the Mineral Rent(as % of GDP) in Other Minerals in 1984?
Offer a very short reply. 10.09. What is the difference between the Mineral Rent(as % of GDP) of Coal in 1983 and the Mineral Rent(as % of GDP) of Natural Gas in 1985?
Ensure brevity in your answer.  -1.15. What is the difference between the Mineral Rent(as % of GDP) in Coal in 1983 and the Mineral Rent(as % of GDP) in Oil in 1985?
Provide a short and direct response. -3.78. What is the difference between the Mineral Rent(as % of GDP) of Coal in 1983 and the Mineral Rent(as % of GDP) of Other Minerals in 1985?
Give a very brief answer. -0.01. What is the difference between the Mineral Rent(as % of GDP) of Natural Gas in 1983 and the Mineral Rent(as % of GDP) of Oil in 1985?
Make the answer very short. -2.29. What is the difference between the Mineral Rent(as % of GDP) in Natural Gas in 1983 and the Mineral Rent(as % of GDP) in Other Minerals in 1985?
Keep it short and to the point. 1.48. What is the difference between the Mineral Rent(as % of GDP) of Oil in 1983 and the Mineral Rent(as % of GDP) of Other Minerals in 1985?
Your answer should be very brief. 10.09. What is the difference between the Mineral Rent(as % of GDP) in Coal in 1984 and the Mineral Rent(as % of GDP) in Natural Gas in 1985?
Offer a terse response. -1.15. What is the difference between the Mineral Rent(as % of GDP) of Coal in 1984 and the Mineral Rent(as % of GDP) of Oil in 1985?
Your answer should be compact. -3.79. What is the difference between the Mineral Rent(as % of GDP) in Coal in 1984 and the Mineral Rent(as % of GDP) in Other Minerals in 1985?
Your answer should be compact. -0.01. What is the difference between the Mineral Rent(as % of GDP) of Natural Gas in 1984 and the Mineral Rent(as % of GDP) of Oil in 1985?
Provide a short and direct response. -2.52. What is the difference between the Mineral Rent(as % of GDP) of Natural Gas in 1984 and the Mineral Rent(as % of GDP) of Other Minerals in 1985?
Offer a very short reply. 1.25. What is the difference between the Mineral Rent(as % of GDP) in Oil in 1984 and the Mineral Rent(as % of GDP) in Other Minerals in 1985?
Your answer should be compact. 9.57. What is the average Mineral Rent(as % of GDP) of Coal per year?
Give a very brief answer. 0.01. What is the average Mineral Rent(as % of GDP) in Natural Gas per year?
Your answer should be very brief. 2.66. What is the average Mineral Rent(as % of GDP) in Oil per year?
Your response must be concise. 7.57. What is the average Mineral Rent(as % of GDP) of Other Minerals per year?
Your response must be concise. 0.03. In the year 1977, what is the difference between the Mineral Rent(as % of GDP) of Coal and Mineral Rent(as % of GDP) of Natural Gas?
Your answer should be compact. -3.99. In the year 1977, what is the difference between the Mineral Rent(as % of GDP) in Coal and Mineral Rent(as % of GDP) in Oil?
Provide a succinct answer. -3.28. In the year 1977, what is the difference between the Mineral Rent(as % of GDP) of Coal and Mineral Rent(as % of GDP) of Other Minerals?
Ensure brevity in your answer.  -0.06. In the year 1977, what is the difference between the Mineral Rent(as % of GDP) in Natural Gas and Mineral Rent(as % of GDP) in Oil?
Ensure brevity in your answer.  0.72. In the year 1977, what is the difference between the Mineral Rent(as % of GDP) of Natural Gas and Mineral Rent(as % of GDP) of Other Minerals?
Give a very brief answer. 3.94. In the year 1977, what is the difference between the Mineral Rent(as % of GDP) of Oil and Mineral Rent(as % of GDP) of Other Minerals?
Your answer should be very brief. 3.22. In the year 1978, what is the difference between the Mineral Rent(as % of GDP) of Coal and Mineral Rent(as % of GDP) of Natural Gas?
Provide a short and direct response. -3.95. In the year 1978, what is the difference between the Mineral Rent(as % of GDP) of Coal and Mineral Rent(as % of GDP) of Oil?
Your answer should be very brief. -7.6. In the year 1978, what is the difference between the Mineral Rent(as % of GDP) in Coal and Mineral Rent(as % of GDP) in Other Minerals?
Your answer should be very brief. -0.03. In the year 1978, what is the difference between the Mineral Rent(as % of GDP) of Natural Gas and Mineral Rent(as % of GDP) of Oil?
Your answer should be very brief. -3.65. In the year 1978, what is the difference between the Mineral Rent(as % of GDP) of Natural Gas and Mineral Rent(as % of GDP) of Other Minerals?
Your response must be concise. 3.92. In the year 1978, what is the difference between the Mineral Rent(as % of GDP) in Oil and Mineral Rent(as % of GDP) in Other Minerals?
Keep it short and to the point. 7.57. In the year 1980, what is the difference between the Mineral Rent(as % of GDP) of Coal and Mineral Rent(as % of GDP) of Natural Gas?
Offer a terse response. -3.79. In the year 1980, what is the difference between the Mineral Rent(as % of GDP) of Coal and Mineral Rent(as % of GDP) of Oil?
Provide a short and direct response. -8.82. In the year 1980, what is the difference between the Mineral Rent(as % of GDP) in Coal and Mineral Rent(as % of GDP) in Other Minerals?
Your answer should be compact. -0.05. In the year 1980, what is the difference between the Mineral Rent(as % of GDP) in Natural Gas and Mineral Rent(as % of GDP) in Oil?
Your response must be concise. -5.03. In the year 1980, what is the difference between the Mineral Rent(as % of GDP) of Natural Gas and Mineral Rent(as % of GDP) of Other Minerals?
Make the answer very short. 3.74. In the year 1980, what is the difference between the Mineral Rent(as % of GDP) in Oil and Mineral Rent(as % of GDP) in Other Minerals?
Ensure brevity in your answer.  8.77. In the year 1981, what is the difference between the Mineral Rent(as % of GDP) in Coal and Mineral Rent(as % of GDP) in Natural Gas?
Give a very brief answer. -3.14. In the year 1981, what is the difference between the Mineral Rent(as % of GDP) of Coal and Mineral Rent(as % of GDP) of Oil?
Ensure brevity in your answer.  -8.2. In the year 1981, what is the difference between the Mineral Rent(as % of GDP) in Coal and Mineral Rent(as % of GDP) in Other Minerals?
Give a very brief answer. -0.02. In the year 1981, what is the difference between the Mineral Rent(as % of GDP) of Natural Gas and Mineral Rent(as % of GDP) of Oil?
Your answer should be very brief. -5.05. In the year 1981, what is the difference between the Mineral Rent(as % of GDP) of Natural Gas and Mineral Rent(as % of GDP) of Other Minerals?
Provide a succinct answer. 3.12. In the year 1981, what is the difference between the Mineral Rent(as % of GDP) in Oil and Mineral Rent(as % of GDP) in Other Minerals?
Your response must be concise. 8.18. In the year 1982, what is the difference between the Mineral Rent(as % of GDP) in Coal and Mineral Rent(as % of GDP) in Natural Gas?
Your response must be concise. -2.45. In the year 1982, what is the difference between the Mineral Rent(as % of GDP) of Coal and Mineral Rent(as % of GDP) of Oil?
Your answer should be compact. -9.19. In the year 1982, what is the difference between the Mineral Rent(as % of GDP) of Coal and Mineral Rent(as % of GDP) of Other Minerals?
Your answer should be very brief. -0.02. In the year 1982, what is the difference between the Mineral Rent(as % of GDP) of Natural Gas and Mineral Rent(as % of GDP) of Oil?
Offer a terse response. -6.74. In the year 1982, what is the difference between the Mineral Rent(as % of GDP) in Natural Gas and Mineral Rent(as % of GDP) in Other Minerals?
Provide a succinct answer. 2.43. In the year 1982, what is the difference between the Mineral Rent(as % of GDP) in Oil and Mineral Rent(as % of GDP) in Other Minerals?
Provide a short and direct response. 9.17. In the year 1983, what is the difference between the Mineral Rent(as % of GDP) in Coal and Mineral Rent(as % of GDP) in Natural Gas?
Make the answer very short. -1.49. In the year 1983, what is the difference between the Mineral Rent(as % of GDP) of Coal and Mineral Rent(as % of GDP) of Oil?
Offer a very short reply. -10.1. In the year 1983, what is the difference between the Mineral Rent(as % of GDP) in Coal and Mineral Rent(as % of GDP) in Other Minerals?
Ensure brevity in your answer.  -0.02. In the year 1983, what is the difference between the Mineral Rent(as % of GDP) of Natural Gas and Mineral Rent(as % of GDP) of Oil?
Offer a terse response. -8.6. In the year 1983, what is the difference between the Mineral Rent(as % of GDP) of Natural Gas and Mineral Rent(as % of GDP) of Other Minerals?
Your response must be concise. 1.47. In the year 1983, what is the difference between the Mineral Rent(as % of GDP) in Oil and Mineral Rent(as % of GDP) in Other Minerals?
Keep it short and to the point. 10.07. In the year 1984, what is the difference between the Mineral Rent(as % of GDP) of Coal and Mineral Rent(as % of GDP) of Natural Gas?
Provide a succinct answer. -1.26. In the year 1984, what is the difference between the Mineral Rent(as % of GDP) of Coal and Mineral Rent(as % of GDP) of Oil?
Keep it short and to the point. -9.58. In the year 1984, what is the difference between the Mineral Rent(as % of GDP) of Coal and Mineral Rent(as % of GDP) of Other Minerals?
Offer a terse response. -0.02. In the year 1984, what is the difference between the Mineral Rent(as % of GDP) of Natural Gas and Mineral Rent(as % of GDP) of Oil?
Your answer should be very brief. -8.32. In the year 1984, what is the difference between the Mineral Rent(as % of GDP) of Natural Gas and Mineral Rent(as % of GDP) of Other Minerals?
Give a very brief answer. 1.25. In the year 1984, what is the difference between the Mineral Rent(as % of GDP) of Oil and Mineral Rent(as % of GDP) of Other Minerals?
Offer a very short reply. 9.57. In the year 1985, what is the difference between the Mineral Rent(as % of GDP) of Coal and Mineral Rent(as % of GDP) of Natural Gas?
Offer a terse response. -1.15. In the year 1985, what is the difference between the Mineral Rent(as % of GDP) in Coal and Mineral Rent(as % of GDP) in Oil?
Your answer should be very brief. -3.78. In the year 1985, what is the difference between the Mineral Rent(as % of GDP) in Coal and Mineral Rent(as % of GDP) in Other Minerals?
Give a very brief answer. -0.01. In the year 1985, what is the difference between the Mineral Rent(as % of GDP) in Natural Gas and Mineral Rent(as % of GDP) in Oil?
Offer a very short reply. -2.64. In the year 1985, what is the difference between the Mineral Rent(as % of GDP) in Natural Gas and Mineral Rent(as % of GDP) in Other Minerals?
Give a very brief answer. 1.14. In the year 1985, what is the difference between the Mineral Rent(as % of GDP) in Oil and Mineral Rent(as % of GDP) in Other Minerals?
Keep it short and to the point. 3.77. What is the ratio of the Mineral Rent(as % of GDP) of Coal in 1977 to that in 1978?
Offer a very short reply. 10.28. What is the ratio of the Mineral Rent(as % of GDP) in Natural Gas in 1977 to that in 1978?
Offer a terse response. 1.01. What is the ratio of the Mineral Rent(as % of GDP) of Oil in 1977 to that in 1978?
Ensure brevity in your answer.  0.43. What is the ratio of the Mineral Rent(as % of GDP) of Other Minerals in 1977 to that in 1978?
Offer a terse response. 1.8. What is the ratio of the Mineral Rent(as % of GDP) of Coal in 1977 to that in 1980?
Your response must be concise. 1.97. What is the ratio of the Mineral Rent(as % of GDP) of Natural Gas in 1977 to that in 1980?
Offer a very short reply. 1.05. What is the ratio of the Mineral Rent(as % of GDP) in Oil in 1977 to that in 1980?
Provide a short and direct response. 0.37. What is the ratio of the Mineral Rent(as % of GDP) in Other Minerals in 1977 to that in 1980?
Your answer should be compact. 1.13. What is the ratio of the Mineral Rent(as % of GDP) in Coal in 1977 to that in 1981?
Offer a very short reply. 0.38. What is the ratio of the Mineral Rent(as % of GDP) in Natural Gas in 1977 to that in 1981?
Your response must be concise. 1.27. What is the ratio of the Mineral Rent(as % of GDP) in Oil in 1977 to that in 1981?
Provide a succinct answer. 0.4. What is the ratio of the Mineral Rent(as % of GDP) in Other Minerals in 1977 to that in 1981?
Your answer should be compact. 1.89. What is the ratio of the Mineral Rent(as % of GDP) in Coal in 1977 to that in 1982?
Offer a terse response. 0.31. What is the ratio of the Mineral Rent(as % of GDP) in Natural Gas in 1977 to that in 1982?
Provide a short and direct response. 1.62. What is the ratio of the Mineral Rent(as % of GDP) of Oil in 1977 to that in 1982?
Your answer should be compact. 0.36. What is the ratio of the Mineral Rent(as % of GDP) of Other Minerals in 1977 to that in 1982?
Make the answer very short. 1.64. What is the ratio of the Mineral Rent(as % of GDP) of Coal in 1977 to that in 1983?
Give a very brief answer. 1.09. What is the ratio of the Mineral Rent(as % of GDP) of Natural Gas in 1977 to that in 1983?
Ensure brevity in your answer.  2.67. What is the ratio of the Mineral Rent(as % of GDP) of Oil in 1977 to that in 1983?
Your response must be concise. 0.32. What is the ratio of the Mineral Rent(as % of GDP) in Other Minerals in 1977 to that in 1983?
Your response must be concise. 2.06. What is the ratio of the Mineral Rent(as % of GDP) of Coal in 1977 to that in 1984?
Offer a very short reply. 26.91. What is the ratio of the Mineral Rent(as % of GDP) in Natural Gas in 1977 to that in 1984?
Ensure brevity in your answer.  3.16. What is the ratio of the Mineral Rent(as % of GDP) of Oil in 1977 to that in 1984?
Offer a terse response. 0.34. What is the ratio of the Mineral Rent(as % of GDP) in Other Minerals in 1977 to that in 1984?
Your response must be concise. 3.72. What is the ratio of the Mineral Rent(as % of GDP) in Coal in 1977 to that in 1985?
Make the answer very short. 1.92. What is the ratio of the Mineral Rent(as % of GDP) in Natural Gas in 1977 to that in 1985?
Keep it short and to the point. 3.48. What is the ratio of the Mineral Rent(as % of GDP) in Oil in 1977 to that in 1985?
Your answer should be compact. 0.87. What is the ratio of the Mineral Rent(as % of GDP) of Other Minerals in 1977 to that in 1985?
Your response must be concise. 4.13. What is the ratio of the Mineral Rent(as % of GDP) of Coal in 1978 to that in 1980?
Your response must be concise. 0.19. What is the ratio of the Mineral Rent(as % of GDP) of Natural Gas in 1978 to that in 1980?
Your response must be concise. 1.04. What is the ratio of the Mineral Rent(as % of GDP) of Oil in 1978 to that in 1980?
Offer a very short reply. 0.86. What is the ratio of the Mineral Rent(as % of GDP) in Other Minerals in 1978 to that in 1980?
Offer a terse response. 0.62. What is the ratio of the Mineral Rent(as % of GDP) in Coal in 1978 to that in 1981?
Your answer should be very brief. 0.04. What is the ratio of the Mineral Rent(as % of GDP) of Natural Gas in 1978 to that in 1981?
Give a very brief answer. 1.25. What is the ratio of the Mineral Rent(as % of GDP) in Oil in 1978 to that in 1981?
Provide a short and direct response. 0.93. What is the ratio of the Mineral Rent(as % of GDP) in Other Minerals in 1978 to that in 1981?
Your answer should be compact. 1.05. What is the ratio of the Mineral Rent(as % of GDP) in Coal in 1978 to that in 1982?
Your answer should be compact. 0.03. What is the ratio of the Mineral Rent(as % of GDP) in Natural Gas in 1978 to that in 1982?
Give a very brief answer. 1.6. What is the ratio of the Mineral Rent(as % of GDP) in Oil in 1978 to that in 1982?
Your answer should be compact. 0.83. What is the ratio of the Mineral Rent(as % of GDP) in Other Minerals in 1978 to that in 1982?
Offer a very short reply. 0.91. What is the ratio of the Mineral Rent(as % of GDP) in Coal in 1978 to that in 1983?
Offer a terse response. 0.11. What is the ratio of the Mineral Rent(as % of GDP) of Natural Gas in 1978 to that in 1983?
Your response must be concise. 2.64. What is the ratio of the Mineral Rent(as % of GDP) in Oil in 1978 to that in 1983?
Your answer should be very brief. 0.75. What is the ratio of the Mineral Rent(as % of GDP) of Other Minerals in 1978 to that in 1983?
Ensure brevity in your answer.  1.14. What is the ratio of the Mineral Rent(as % of GDP) in Coal in 1978 to that in 1984?
Ensure brevity in your answer.  2.62. What is the ratio of the Mineral Rent(as % of GDP) in Natural Gas in 1978 to that in 1984?
Provide a short and direct response. 3.12. What is the ratio of the Mineral Rent(as % of GDP) of Oil in 1978 to that in 1984?
Your answer should be compact. 0.79. What is the ratio of the Mineral Rent(as % of GDP) in Other Minerals in 1978 to that in 1984?
Ensure brevity in your answer.  2.06. What is the ratio of the Mineral Rent(as % of GDP) of Coal in 1978 to that in 1985?
Provide a succinct answer. 0.19. What is the ratio of the Mineral Rent(as % of GDP) of Natural Gas in 1978 to that in 1985?
Give a very brief answer. 3.44. What is the ratio of the Mineral Rent(as % of GDP) in Oil in 1978 to that in 1985?
Your answer should be very brief. 2.01. What is the ratio of the Mineral Rent(as % of GDP) of Other Minerals in 1978 to that in 1985?
Provide a short and direct response. 2.29. What is the ratio of the Mineral Rent(as % of GDP) in Coal in 1980 to that in 1981?
Your answer should be compact. 0.19. What is the ratio of the Mineral Rent(as % of GDP) in Natural Gas in 1980 to that in 1981?
Keep it short and to the point. 1.2. What is the ratio of the Mineral Rent(as % of GDP) of Oil in 1980 to that in 1981?
Your answer should be compact. 1.07. What is the ratio of the Mineral Rent(as % of GDP) of Other Minerals in 1980 to that in 1981?
Keep it short and to the point. 1.68. What is the ratio of the Mineral Rent(as % of GDP) in Coal in 1980 to that in 1982?
Offer a very short reply. 0.16. What is the ratio of the Mineral Rent(as % of GDP) of Natural Gas in 1980 to that in 1982?
Your response must be concise. 1.54. What is the ratio of the Mineral Rent(as % of GDP) in Oil in 1980 to that in 1982?
Ensure brevity in your answer.  0.96. What is the ratio of the Mineral Rent(as % of GDP) in Other Minerals in 1980 to that in 1982?
Your response must be concise. 1.45. What is the ratio of the Mineral Rent(as % of GDP) of Coal in 1980 to that in 1983?
Your answer should be very brief. 0.55. What is the ratio of the Mineral Rent(as % of GDP) of Natural Gas in 1980 to that in 1983?
Give a very brief answer. 2.53. What is the ratio of the Mineral Rent(as % of GDP) in Oil in 1980 to that in 1983?
Ensure brevity in your answer.  0.87. What is the ratio of the Mineral Rent(as % of GDP) of Other Minerals in 1980 to that in 1983?
Provide a succinct answer. 1.83. What is the ratio of the Mineral Rent(as % of GDP) in Coal in 1980 to that in 1984?
Keep it short and to the point. 13.63. What is the ratio of the Mineral Rent(as % of GDP) of Natural Gas in 1980 to that in 1984?
Provide a short and direct response. 3. What is the ratio of the Mineral Rent(as % of GDP) in Oil in 1980 to that in 1984?
Offer a terse response. 0.92. What is the ratio of the Mineral Rent(as % of GDP) of Other Minerals in 1980 to that in 1984?
Offer a very short reply. 3.3. What is the ratio of the Mineral Rent(as % of GDP) of Coal in 1980 to that in 1985?
Your answer should be very brief. 0.97. What is the ratio of the Mineral Rent(as % of GDP) of Natural Gas in 1980 to that in 1985?
Keep it short and to the point. 3.3. What is the ratio of the Mineral Rent(as % of GDP) of Oil in 1980 to that in 1985?
Keep it short and to the point. 2.33. What is the ratio of the Mineral Rent(as % of GDP) in Other Minerals in 1980 to that in 1985?
Make the answer very short. 3.67. What is the ratio of the Mineral Rent(as % of GDP) of Coal in 1981 to that in 1982?
Provide a succinct answer. 0.82. What is the ratio of the Mineral Rent(as % of GDP) in Natural Gas in 1981 to that in 1982?
Ensure brevity in your answer.  1.28. What is the ratio of the Mineral Rent(as % of GDP) in Oil in 1981 to that in 1982?
Give a very brief answer. 0.89. What is the ratio of the Mineral Rent(as % of GDP) of Other Minerals in 1981 to that in 1982?
Keep it short and to the point. 0.86. What is the ratio of the Mineral Rent(as % of GDP) in Natural Gas in 1981 to that in 1983?
Your answer should be compact. 2.11. What is the ratio of the Mineral Rent(as % of GDP) in Oil in 1981 to that in 1983?
Your response must be concise. 0.81. What is the ratio of the Mineral Rent(as % of GDP) of Other Minerals in 1981 to that in 1983?
Offer a very short reply. 1.09. What is the ratio of the Mineral Rent(as % of GDP) of Coal in 1981 to that in 1984?
Provide a short and direct response. 71.41. What is the ratio of the Mineral Rent(as % of GDP) in Natural Gas in 1981 to that in 1984?
Ensure brevity in your answer.  2.5. What is the ratio of the Mineral Rent(as % of GDP) of Oil in 1981 to that in 1984?
Ensure brevity in your answer.  0.86. What is the ratio of the Mineral Rent(as % of GDP) of Other Minerals in 1981 to that in 1984?
Provide a succinct answer. 1.96. What is the ratio of the Mineral Rent(as % of GDP) in Coal in 1981 to that in 1985?
Give a very brief answer. 5.09. What is the ratio of the Mineral Rent(as % of GDP) of Natural Gas in 1981 to that in 1985?
Your response must be concise. 2.74. What is the ratio of the Mineral Rent(as % of GDP) of Oil in 1981 to that in 1985?
Ensure brevity in your answer.  2.17. What is the ratio of the Mineral Rent(as % of GDP) of Other Minerals in 1981 to that in 1985?
Your answer should be compact. 2.19. What is the ratio of the Mineral Rent(as % of GDP) of Coal in 1982 to that in 1983?
Offer a very short reply. 3.53. What is the ratio of the Mineral Rent(as % of GDP) in Natural Gas in 1982 to that in 1983?
Give a very brief answer. 1.65. What is the ratio of the Mineral Rent(as % of GDP) in Oil in 1982 to that in 1983?
Your answer should be very brief. 0.91. What is the ratio of the Mineral Rent(as % of GDP) of Other Minerals in 1982 to that in 1983?
Give a very brief answer. 1.26. What is the ratio of the Mineral Rent(as % of GDP) of Coal in 1982 to that in 1984?
Keep it short and to the point. 86.99. What is the ratio of the Mineral Rent(as % of GDP) in Natural Gas in 1982 to that in 1984?
Offer a terse response. 1.95. What is the ratio of the Mineral Rent(as % of GDP) of Oil in 1982 to that in 1984?
Your response must be concise. 0.96. What is the ratio of the Mineral Rent(as % of GDP) in Other Minerals in 1982 to that in 1984?
Provide a short and direct response. 2.27. What is the ratio of the Mineral Rent(as % of GDP) in Coal in 1982 to that in 1985?
Ensure brevity in your answer.  6.2. What is the ratio of the Mineral Rent(as % of GDP) of Natural Gas in 1982 to that in 1985?
Provide a short and direct response. 2.14. What is the ratio of the Mineral Rent(as % of GDP) in Oil in 1982 to that in 1985?
Ensure brevity in your answer.  2.43. What is the ratio of the Mineral Rent(as % of GDP) in Other Minerals in 1982 to that in 1985?
Your response must be concise. 2.53. What is the ratio of the Mineral Rent(as % of GDP) in Coal in 1983 to that in 1984?
Make the answer very short. 24.62. What is the ratio of the Mineral Rent(as % of GDP) in Natural Gas in 1983 to that in 1984?
Keep it short and to the point. 1.18. What is the ratio of the Mineral Rent(as % of GDP) of Oil in 1983 to that in 1984?
Your response must be concise. 1.05. What is the ratio of the Mineral Rent(as % of GDP) in Other Minerals in 1983 to that in 1984?
Your answer should be compact. 1.8. What is the ratio of the Mineral Rent(as % of GDP) in Coal in 1983 to that in 1985?
Provide a succinct answer. 1.75. What is the ratio of the Mineral Rent(as % of GDP) in Natural Gas in 1983 to that in 1985?
Your answer should be very brief. 1.3. What is the ratio of the Mineral Rent(as % of GDP) in Oil in 1983 to that in 1985?
Your answer should be very brief. 2.67. What is the ratio of the Mineral Rent(as % of GDP) of Other Minerals in 1983 to that in 1985?
Make the answer very short. 2.01. What is the ratio of the Mineral Rent(as % of GDP) in Coal in 1984 to that in 1985?
Your answer should be compact. 0.07. What is the ratio of the Mineral Rent(as % of GDP) of Natural Gas in 1984 to that in 1985?
Ensure brevity in your answer.  1.1. What is the ratio of the Mineral Rent(as % of GDP) of Oil in 1984 to that in 1985?
Give a very brief answer. 2.53. What is the ratio of the Mineral Rent(as % of GDP) of Other Minerals in 1984 to that in 1985?
Make the answer very short. 1.11. What is the difference between the highest and the second highest Mineral Rent(as % of GDP) of Coal?
Provide a short and direct response. 0. What is the difference between the highest and the second highest Mineral Rent(as % of GDP) in Natural Gas?
Your response must be concise. 0.05. What is the difference between the highest and the second highest Mineral Rent(as % of GDP) of Oil?
Keep it short and to the point. 0.52. What is the difference between the highest and the second highest Mineral Rent(as % of GDP) in Other Minerals?
Offer a very short reply. 0.01. What is the difference between the highest and the lowest Mineral Rent(as % of GDP) of Coal?
Ensure brevity in your answer.  0.02. What is the difference between the highest and the lowest Mineral Rent(as % of GDP) of Natural Gas?
Your response must be concise. 2.85. What is the difference between the highest and the lowest Mineral Rent(as % of GDP) of Oil?
Offer a very short reply. 6.82. What is the difference between the highest and the lowest Mineral Rent(as % of GDP) of Other Minerals?
Give a very brief answer. 0.05. 